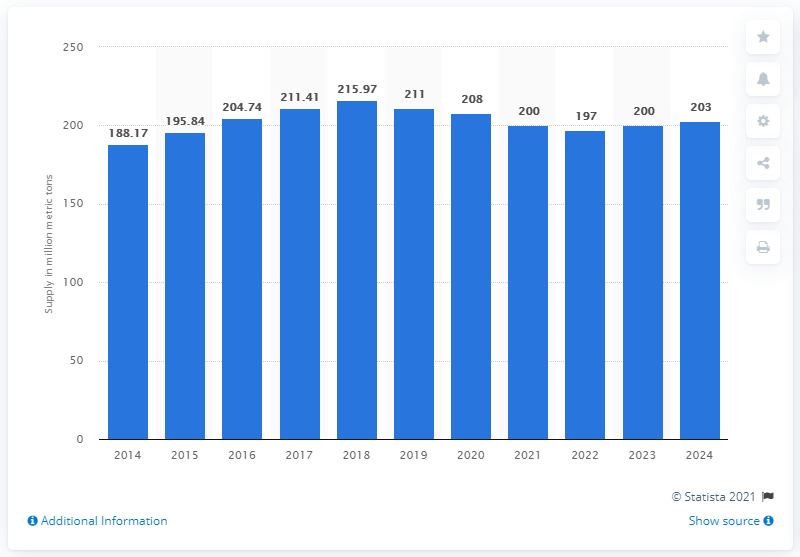Give some essential details in this illustration. It is estimated that the global supply of urea fertilizers will reach a certain quantity in the year 2024 and continue to increase in the following years. 